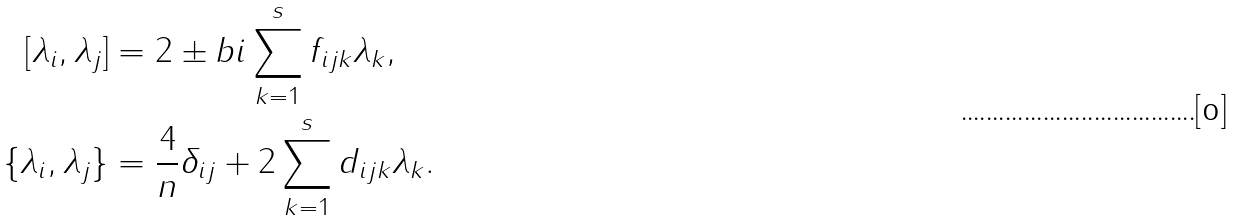<formula> <loc_0><loc_0><loc_500><loc_500>[ \lambda _ { i } , \lambda _ { j } ] & = 2 \pm b { i } \sum _ { k = 1 } ^ { s } f _ { i j k } \lambda _ { k } , \\ \{ \lambda _ { i } , \lambda _ { j } \} & = \frac { 4 } { n } \delta _ { i j } + 2 \sum _ { k = 1 } ^ { s } d _ { i j k } \lambda _ { k } .</formula> 